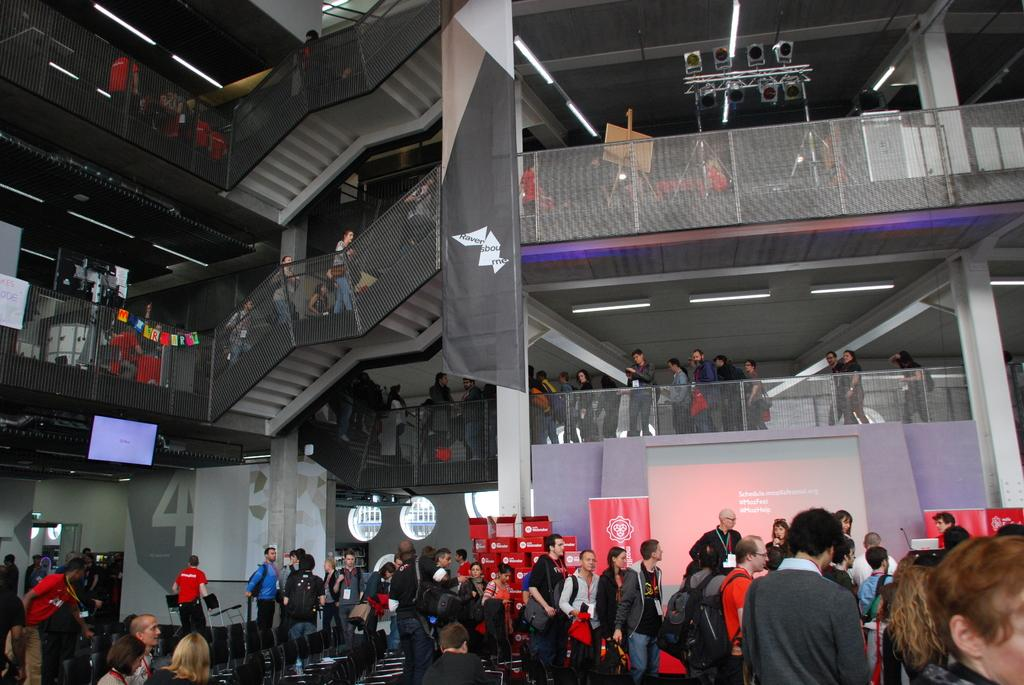Who or what can be seen at the bottom of the image? There are people at the bottom of the image. What architectural feature is visible in the background of the image? There is a staircase in the background of the image. What other elements can be seen in the background of the image? There is a railing, a board, lights, pillars, a screen, and banners with text in the background of the image. How many porters are carrying the banners in the image? There are no porters present in the image; it only shows people, a staircase, a railing, a board, lights, pillars, a screen, and banners with text. What is the limit of the screen's resolution in the image? The image does not provide information about the screen's resolution, so it cannot be determined. 